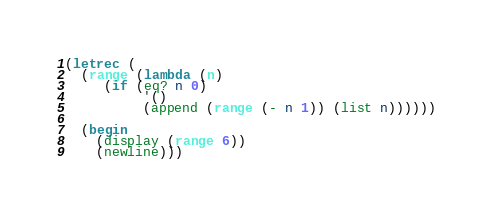Convert code to text. <code><loc_0><loc_0><loc_500><loc_500><_Scheme_>(letrec (
  (range (lambda (n)
     (if (eq? n 0) 
          '()
          (append (range (- n 1)) (list n))))))

  (begin
    (display (range 6))
    (newline)))
</code> 